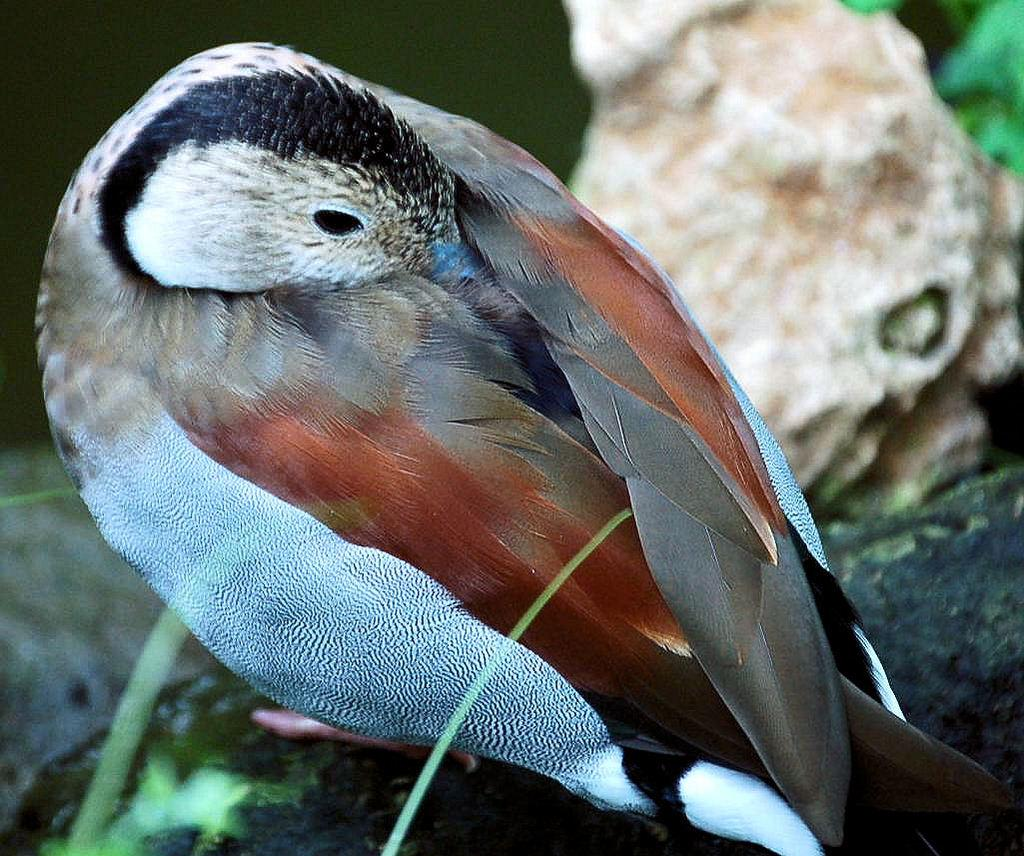What type of animal is in the image? There is a bird in the image. Where is the bird located? The bird is on a tree. What other object can be seen on the right side of the image? There is a rock on the right side of the image. What type of cap is the bird wearing in the image? There is no cap present in the image; the bird is not wearing any clothing. 